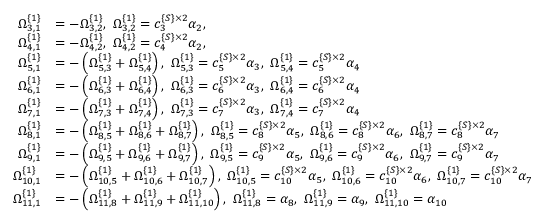Convert formula to latex. <formula><loc_0><loc_0><loc_500><loc_500>\begin{array} { r l } { \Omega _ { 3 , 1 } ^ { \{ 1 \} } } & { = - \Omega _ { 3 , 2 } ^ { \{ 1 \} } , \ \Omega _ { 3 , 2 } ^ { \{ 1 \} } = c _ { 3 } ^ { \{ S \} \times 2 } \alpha _ { 2 } , } \\ { \Omega _ { 4 , 1 } ^ { \{ 1 \} } } & { = - \Omega _ { 4 , 2 } ^ { \{ 1 \} } , \ \Omega _ { 4 , 2 } ^ { \{ 1 \} } = c _ { 4 } ^ { \{ S \} \times 2 } \alpha _ { 2 } , } \\ { \Omega _ { 5 , 1 } ^ { \{ 1 \} } } & { = - \left ( \Omega _ { 5 , 3 } ^ { \{ 1 \} } + \Omega _ { 5 , 4 } ^ { \{ 1 \} } \right ) , \ \Omega _ { 5 , 3 } ^ { \{ 1 \} } = c _ { 5 } ^ { \{ S \} \times 2 } \alpha _ { 3 } , \ \Omega _ { 5 , 4 } ^ { \{ 1 \} } = c _ { 5 } ^ { \{ S \} \times 2 } \alpha _ { 4 } } \\ { \Omega _ { 6 , 1 } ^ { \{ 1 \} } } & { = - \left ( \Omega _ { 6 , 3 } ^ { \{ 1 \} } + \Omega _ { 6 , 4 } ^ { \{ 1 \} } \right ) , \ \Omega _ { 6 , 3 } ^ { \{ 1 \} } = c _ { 6 } ^ { \{ S \} \times 2 } \alpha _ { 3 } , \ \Omega _ { 6 , 4 } ^ { \{ 1 \} } = c _ { 6 } ^ { \{ S \} \times 2 } \alpha _ { 4 } } \\ { \Omega _ { 7 , 1 } ^ { \{ 1 \} } } & { = - \left ( \Omega _ { 7 , 3 } ^ { \{ 1 \} } + \Omega _ { 7 , 4 } ^ { \{ 1 \} } \right ) , \ \Omega _ { 7 , 3 } ^ { \{ 1 \} } = c _ { 7 } ^ { \{ S \} \times 2 } \alpha _ { 3 } , \ \Omega _ { 7 , 4 } ^ { \{ 1 \} } = c _ { 7 } ^ { \{ S \} \times 2 } \alpha _ { 4 } } \\ { \Omega _ { 8 , 1 } ^ { \{ 1 \} } } & { = - \left ( \Omega _ { 8 , 5 } ^ { \{ 1 \} } + \Omega _ { 8 , 6 } ^ { \{ 1 \} } + \Omega _ { 8 , 7 } ^ { \{ 1 \} } \right ) , \ \Omega _ { 8 , 5 } ^ { \{ 1 \} } = c _ { 8 } ^ { \{ S \} \times 2 } \alpha _ { 5 } , \ \Omega _ { 8 , 6 } ^ { \{ 1 \} } = c _ { 8 } ^ { \{ S \} \times 2 } \alpha _ { 6 } , \ \Omega _ { 8 , 7 } ^ { \{ 1 \} } = c _ { 8 } ^ { \{ S \} \times 2 } \alpha _ { 7 } } \\ { \Omega _ { 9 , 1 } ^ { \{ 1 \} } } & { = - \left ( \Omega _ { 9 , 5 } ^ { \{ 1 \} } + \Omega _ { 9 , 6 } ^ { \{ 1 \} } + \Omega _ { 9 , 7 } ^ { \{ 1 \} } \right ) , \ \Omega _ { 9 , 5 } ^ { \{ 1 \} } = c _ { 9 } ^ { \{ S \} \times 2 } \alpha _ { 5 } , \ \Omega _ { 9 , 6 } ^ { \{ 1 \} } = c _ { 9 } ^ { \{ S \} \times 2 } \alpha _ { 6 } , \ \Omega _ { 9 , 7 } ^ { \{ 1 \} } = c _ { 9 } ^ { \{ S \} \times 2 } \alpha _ { 7 } } \\ { \Omega _ { 1 0 , 1 } ^ { \{ 1 \} } } & { = - \left ( \Omega _ { 1 0 , 5 } ^ { \{ 1 \} } + \Omega _ { 1 0 , 6 } ^ { \{ 1 \} } + \Omega _ { 1 0 , 7 } ^ { \{ 1 \} } \right ) , \ \Omega _ { 1 0 , 5 } ^ { \{ 1 \} } = c _ { 1 0 } ^ { \{ S \} \times 2 } \alpha _ { 5 } , \ \Omega _ { 1 0 , 6 } ^ { \{ 1 \} } = c _ { 1 0 } ^ { \{ S \} \times 2 } \alpha _ { 6 } , \ \Omega _ { 1 0 , 7 } ^ { \{ 1 \} } = c _ { 1 0 } ^ { \{ S \} \times 2 } \alpha _ { 7 } } \\ { \Omega _ { 1 1 , 1 } ^ { \{ 1 \} } } & { = - \left ( \Omega _ { 1 1 , 8 } ^ { \{ 1 \} } + \Omega _ { 1 1 , 9 } ^ { \{ 1 \} } + \Omega _ { 1 1 , 1 0 } ^ { \{ 1 \} } \right ) , \ \Omega _ { 1 1 , 8 } ^ { \{ 1 \} } = \alpha _ { 8 } , \ \Omega _ { 1 1 , 9 } ^ { \{ 1 \} } = \alpha _ { 9 } , \ \Omega _ { 1 1 , 1 0 } ^ { \{ 1 \} } = \alpha _ { 1 0 } } \end{array}</formula> 